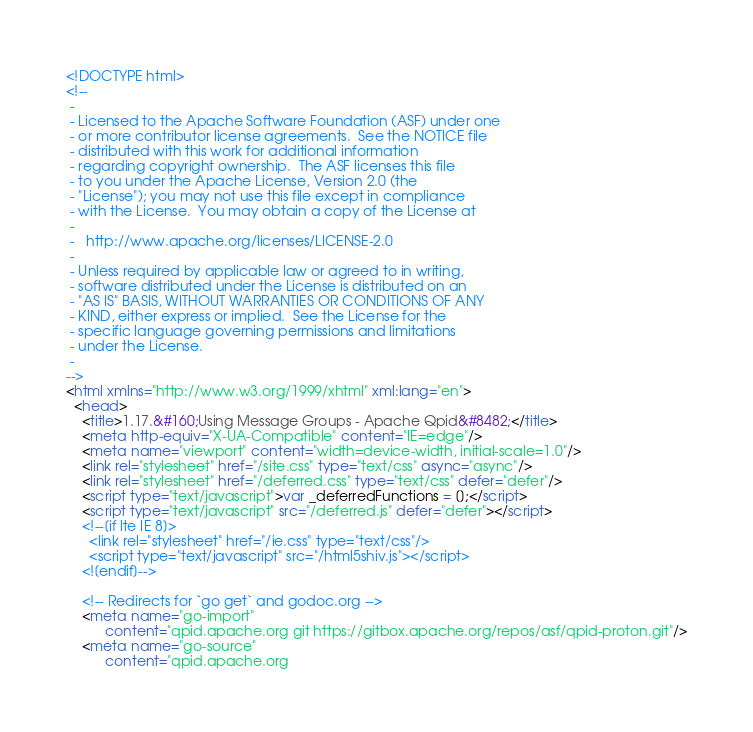<code> <loc_0><loc_0><loc_500><loc_500><_HTML_><!DOCTYPE html>
<!--
 -
 - Licensed to the Apache Software Foundation (ASF) under one
 - or more contributor license agreements.  See the NOTICE file
 - distributed with this work for additional information
 - regarding copyright ownership.  The ASF licenses this file
 - to you under the Apache License, Version 2.0 (the
 - "License"); you may not use this file except in compliance
 - with the License.  You may obtain a copy of the License at
 -
 -   http://www.apache.org/licenses/LICENSE-2.0
 -
 - Unless required by applicable law or agreed to in writing,
 - software distributed under the License is distributed on an
 - "AS IS" BASIS, WITHOUT WARRANTIES OR CONDITIONS OF ANY
 - KIND, either express or implied.  See the License for the
 - specific language governing permissions and limitations
 - under the License.
 -
-->
<html xmlns="http://www.w3.org/1999/xhtml" xml:lang="en">
  <head>
    <title>1.17.&#160;Using Message Groups - Apache Qpid&#8482;</title>
    <meta http-equiv="X-UA-Compatible" content="IE=edge"/>
    <meta name="viewport" content="width=device-width, initial-scale=1.0"/>
    <link rel="stylesheet" href="/site.css" type="text/css" async="async"/>
    <link rel="stylesheet" href="/deferred.css" type="text/css" defer="defer"/>
    <script type="text/javascript">var _deferredFunctions = [];</script>
    <script type="text/javascript" src="/deferred.js" defer="defer"></script>
    <!--[if lte IE 8]>
      <link rel="stylesheet" href="/ie.css" type="text/css"/>
      <script type="text/javascript" src="/html5shiv.js"></script>
    <![endif]-->

    <!-- Redirects for `go get` and godoc.org -->
    <meta name="go-import"
          content="qpid.apache.org git https://gitbox.apache.org/repos/asf/qpid-proton.git"/>
    <meta name="go-source"
          content="qpid.apache.org</code> 